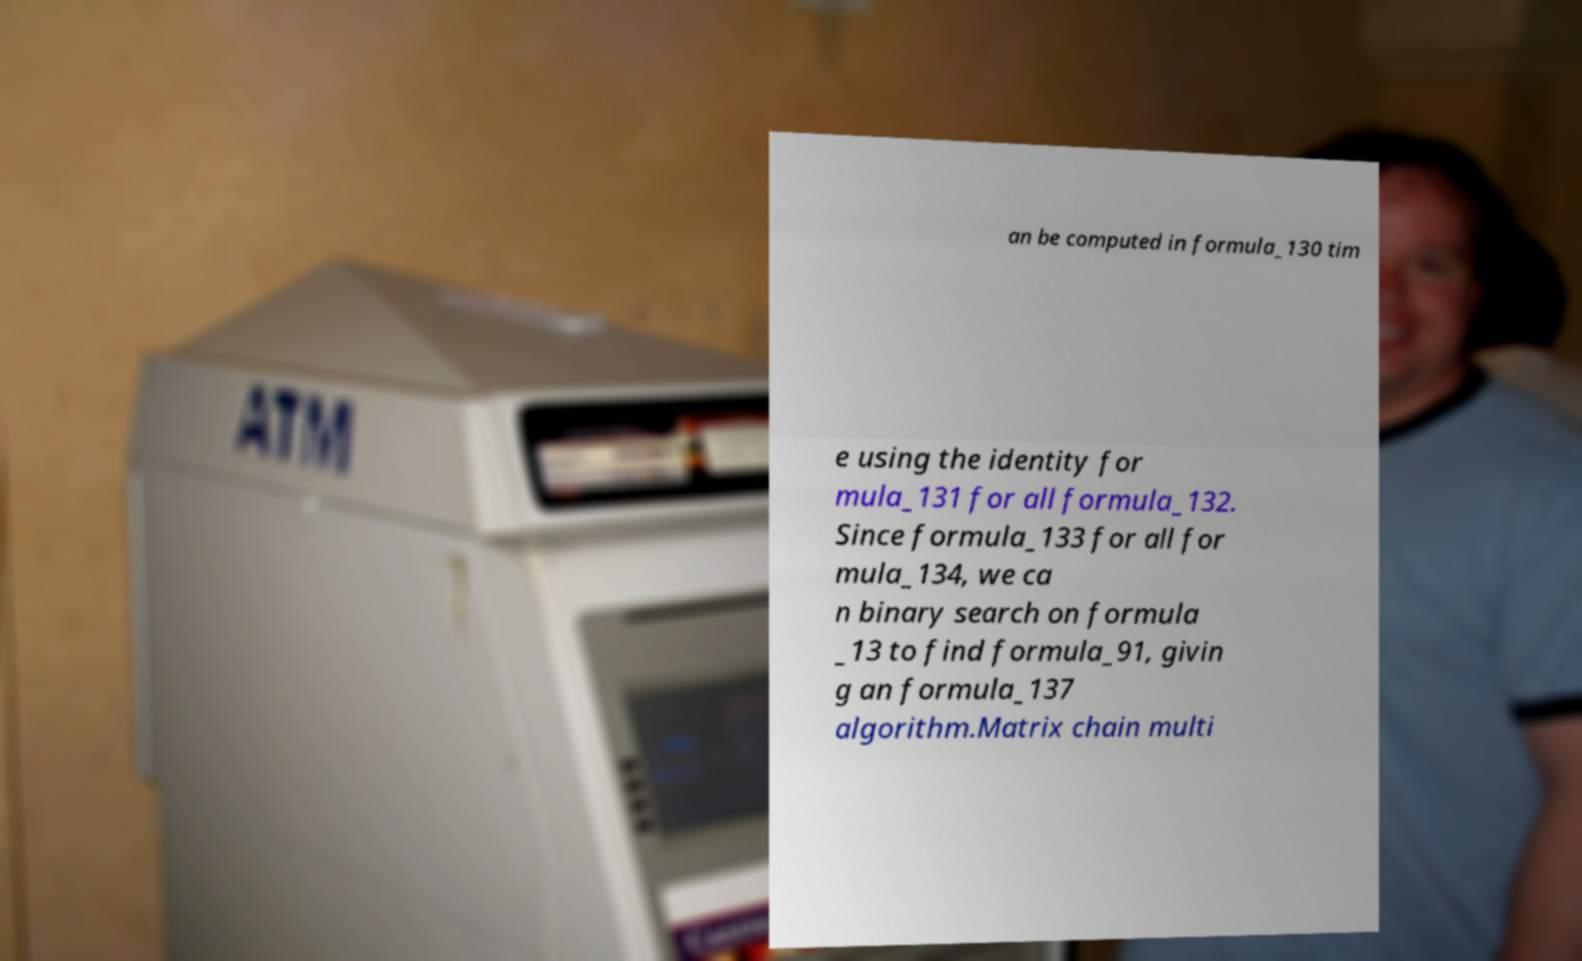Please identify and transcribe the text found in this image. an be computed in formula_130 tim e using the identity for mula_131 for all formula_132. Since formula_133 for all for mula_134, we ca n binary search on formula _13 to find formula_91, givin g an formula_137 algorithm.Matrix chain multi 